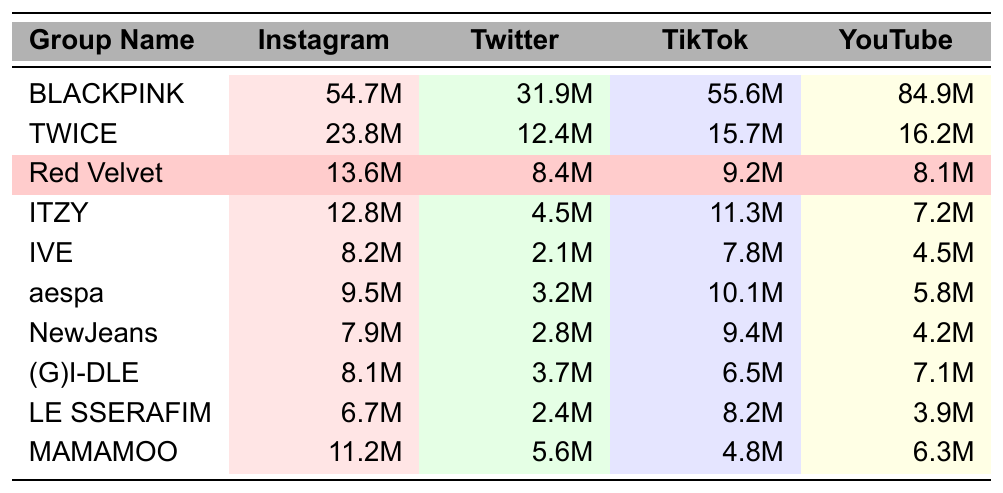What is the highest number of Instagram followers among the K-pop girl groups? Looking at the Instagram followers column, BLACKPINK has the highest count at 54.7 million.
Answer: 54.7M How many Twitter followers does Red Velvet have? Red Velvet's Twitter followers are clearly listed in the table, showing 8.4 million.
Answer: 8.4M Which group has the lowest TikTok followers? By scanning the TikTok followers column, IVE has the lowest count at 7.8 million followers.
Answer: 7.8M What is the difference between BLACKPINK's and TWICE's YouTube subscribers? BLACKPINK has 84.9 million YouTube subscribers, and TWICE has 16.2 million. The difference is 84.9M - 16.2M = 68.7M.
Answer: 68.7M Is Red Velvet the only group with more YouTube subscribers than IVE? Red Velvet has 8.1 million subscribers, while IVE has only 4.5 million. A comparison shows that Red Velvet has more than IVE, but other groups like MAMAMOO also have more than IVE (6.3M). Thus, the statement is false.
Answer: No What is the total number of Instagram followers for the top three groups: BLACKPINK, TWICE, and Red Velvet? BLACKPINK has 54.7M, TWICE has 23.8M, and Red Velvet has 13.6M. Adding these: 54.7M + 23.8M + 13.6M = 92.1M.
Answer: 92.1M Are there any groups that have more followers on TikTok than Instagram? By comparing the TikTok and Instagram follower counts, aespa has 10.1M on TikTok and 9.5M on Instagram, thus it is greater. Thus, the answer is yes.
Answer: Yes What is the average number of YouTube subscribers for the girl groups listed? Summing the YouTube subscribers: 84.9M + 16.2M + 8.1M + 7.2M + 4.5M + 5.8M + 4.2M + 7.1M + 3.9M + 6.3M = 138.1M. We then divide by the 10 groups: 138.1M / 10 = 13.81M.
Answer: 13.81M Which K-pop girl group has the second highest Twitter followers? The second highest Twitter followers belong to TWICE, which has 12.4 million, immediately following BLACKPINK with 31.9 million.
Answer: TWICE How does Red Velvet's TikTok followers compare to MAMAMOO's? Red Velvet has 9.2M TikTok followers while MAMAMOO has 4.8M. Thus, Red Velvet has more TikTok followers than MAMAMOO.
Answer: Red Velvet has more Who has the most overall social media followers combined? Adding up all the follower counts for each group and comparing them shows BLACKPINK has the most combined counts.
Answer: BLACKPINK 